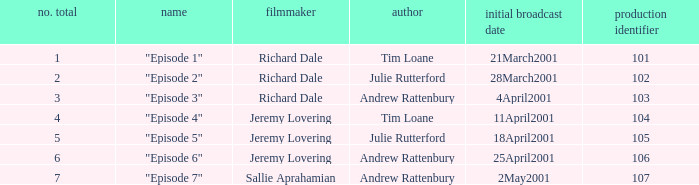When did the episodes first air that had a production code of 107? 2May2001. 